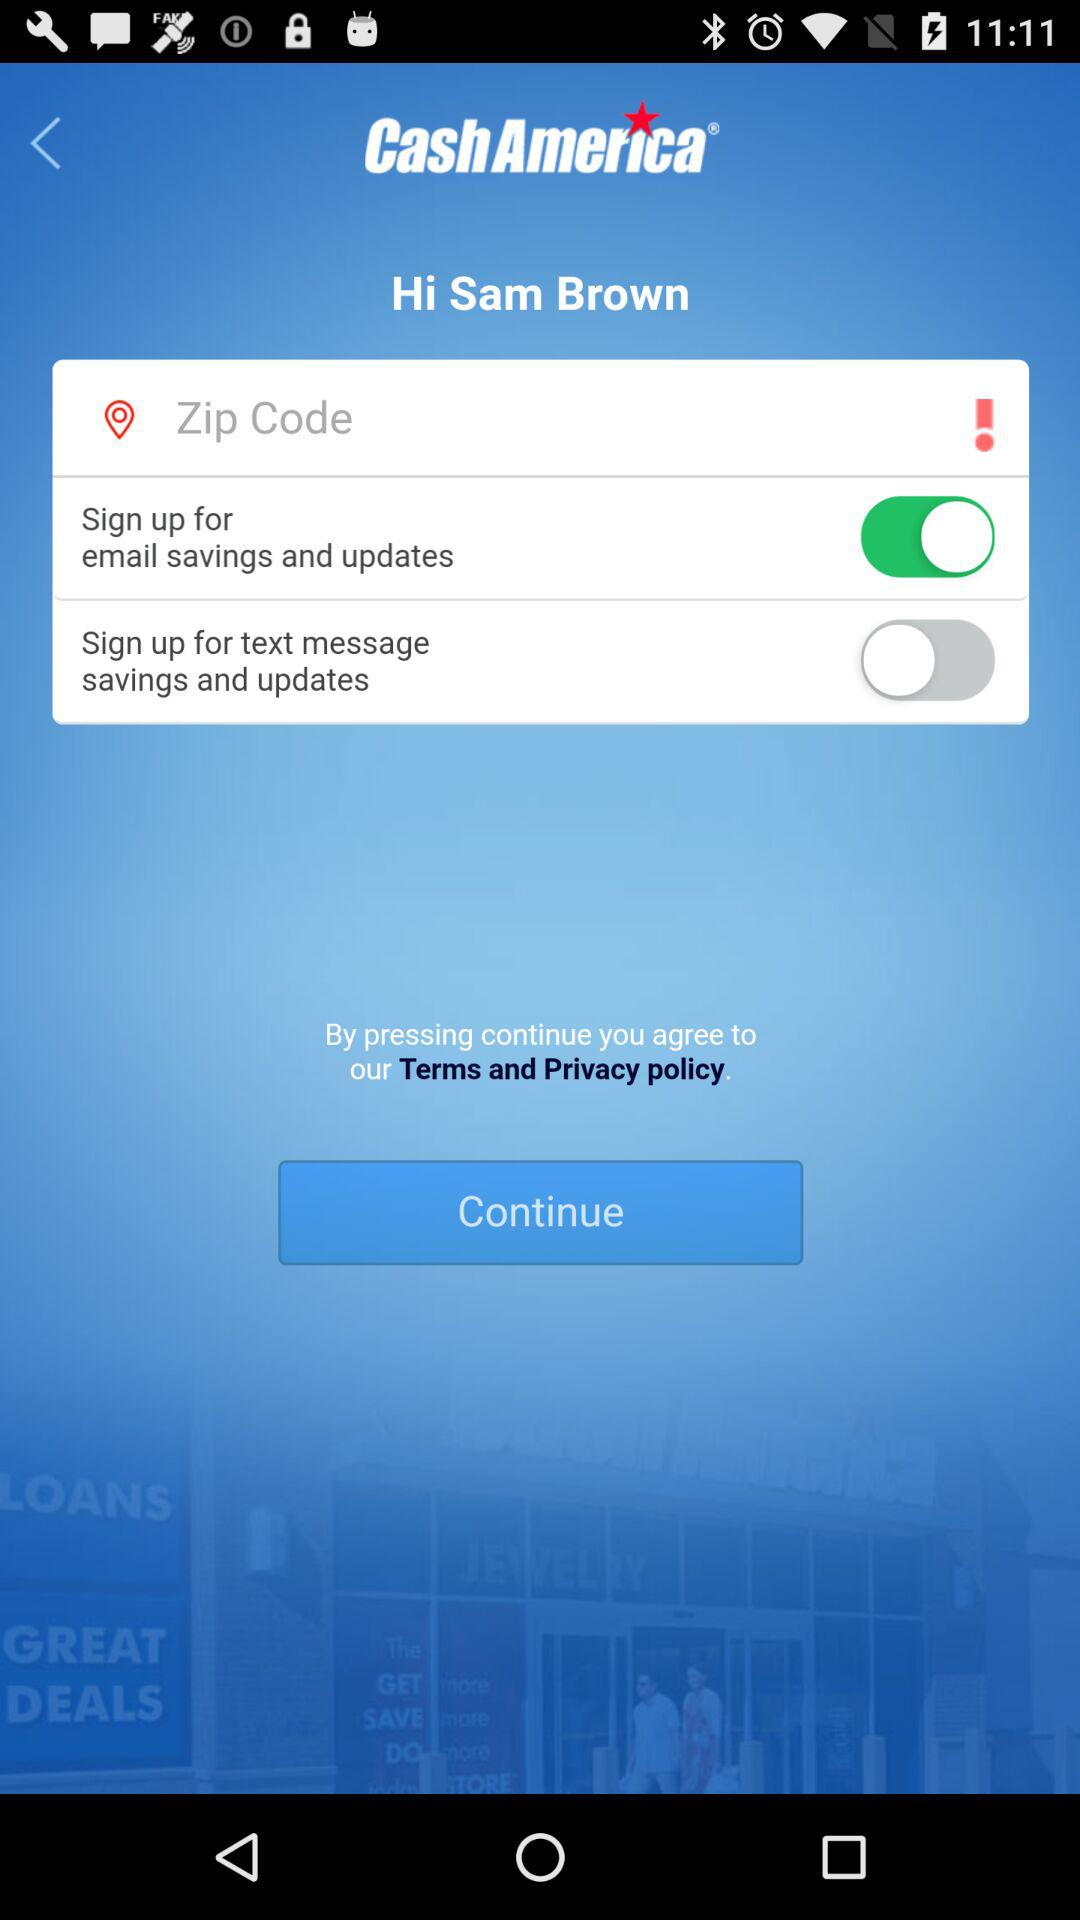What is the name of the user? The name of the user is Sam Brown. 